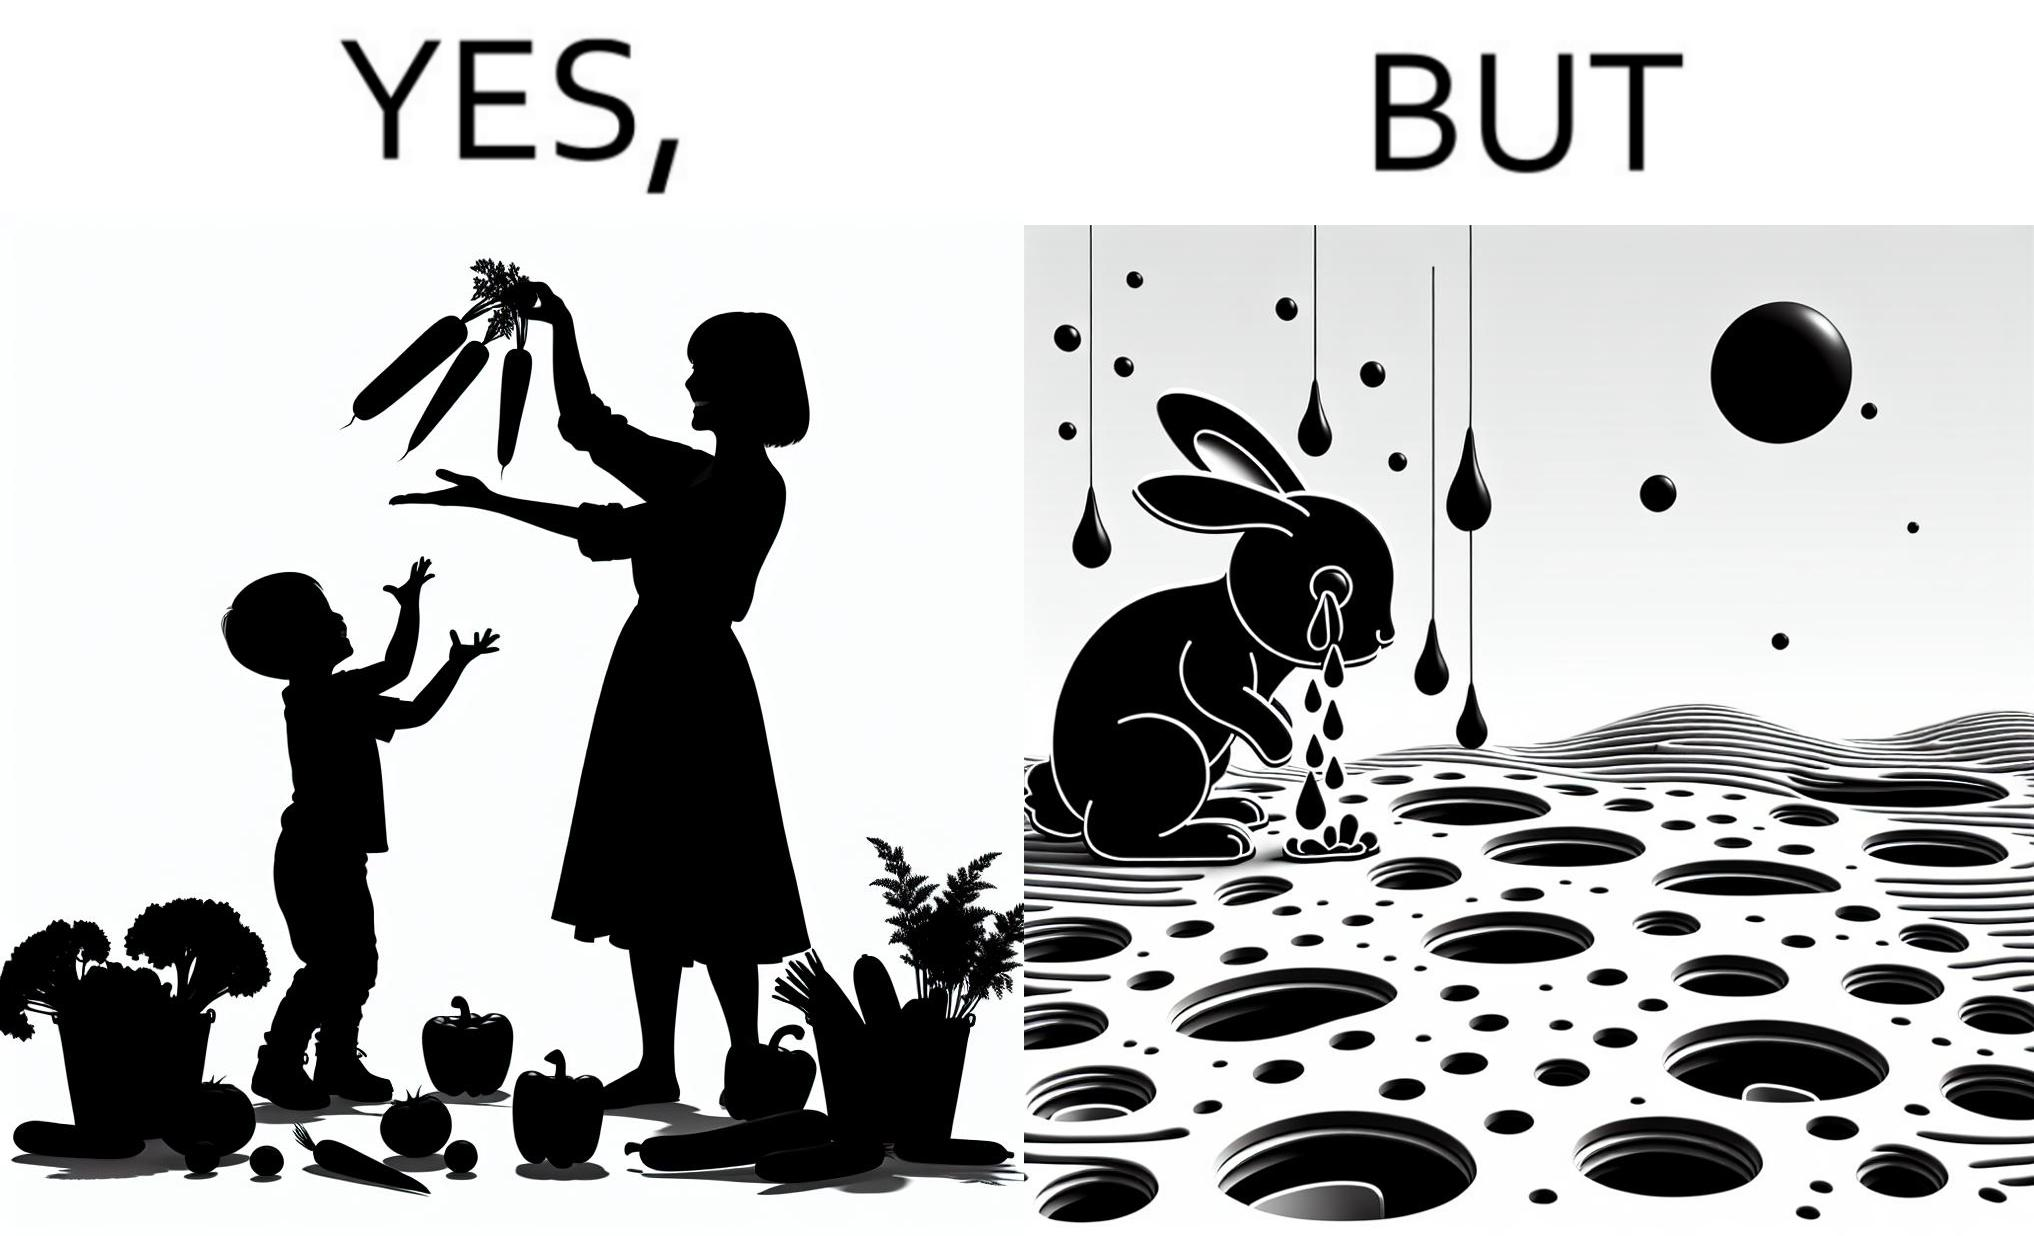Explain why this image is satirical. The images are ironic since they show how on one hand humans choose to play with and waste foods like vegetables while the animals are unable to eat enough food and end up starving due to lack of food 